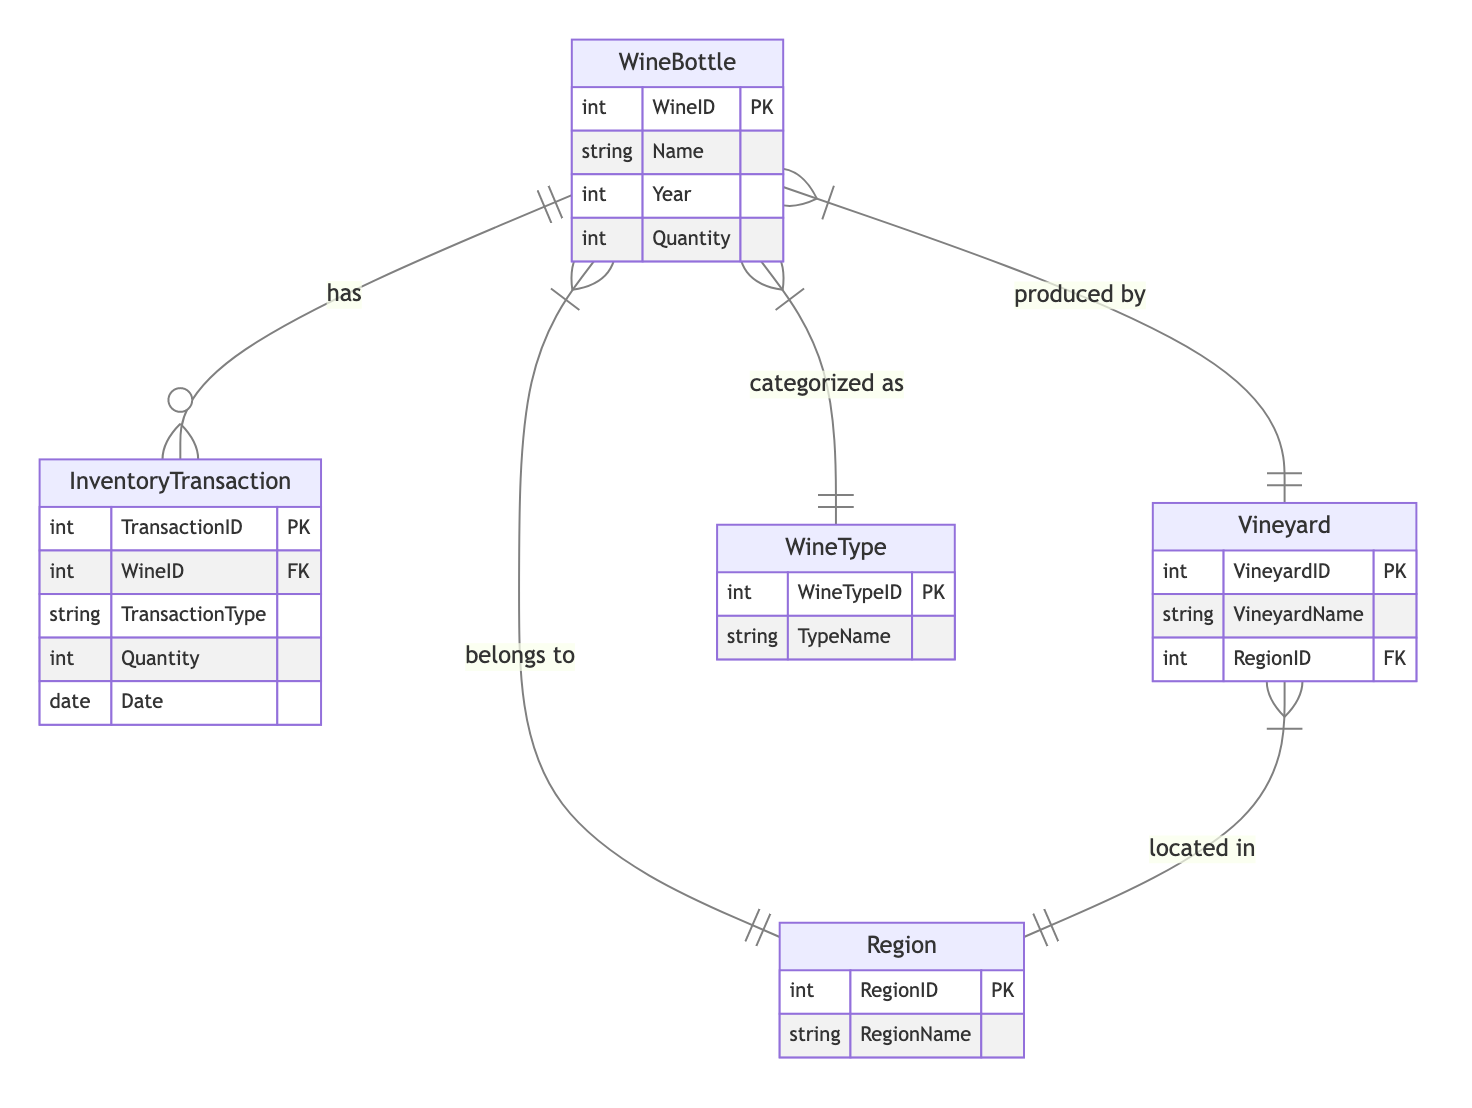What entities are included in the diagram? The diagram consists of five entities: WineBottle, Region, Vineyard, WineType, and InventoryTransaction. These entities represent the various components of the wine inventory management system.
Answer: WineBottle, Region, Vineyard, WineType, InventoryTransaction How many attributes does the WineBottle entity have? The WineBottle entity has five attributes: WineID, Name, Year, Region, and Quantity. Each attribute provides specific details about the wine bottle.
Answer: 5 Which entity has the primary key named VineyardID? The Vineyard entity has the primary key named VineyardID, which uniquely identifies each vineyard in the inventory management system.
Answer: Vineyard What relationship connects WineBottle and Region? The relationship connecting WineBottle and Region is called "WineBottle_Region," indicating that each wine bottle belongs to one region.
Answer: WineBottle_Region How many relationships are illustrated in the diagram? There are four relationships illustrated in the diagram, showcasing how the entities interact with one another in the wine inventory management system.
Answer: 4 Which entity is categorized as WineType? The WineBottle entity is categorized as WineType, which implies that each wine bottle can be linked to a specific type of wine listed in the WineType entity.
Answer: WineBottle What’s the foreign key in the InventoryTransaction entity? The foreign key in the InventoryTransaction entity is WineID, which links each transaction to a specific wine bottle in the WineBottle entity.
Answer: WineID Which entity is produced by a Vineyard? The entity produced by a Vineyard is the WineBottle, which indicates that each wine bottle is associated with a vineyard where it was produced.
Answer: WineBottle Which entity has a relationship with both Region and Vineyard? The Vineyard entity has a relationship with both Region and WineBottle, indicating that vineyards are located in regions and produce wine bottles.
Answer: Vineyard 